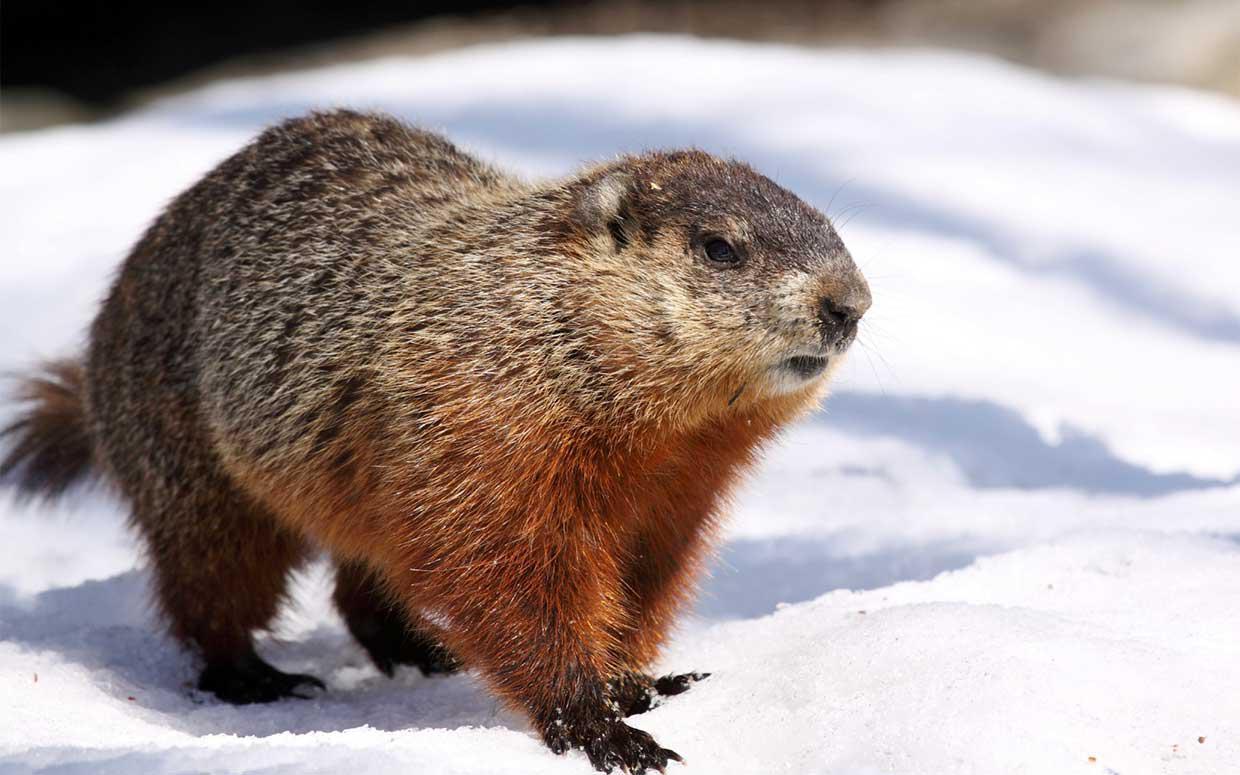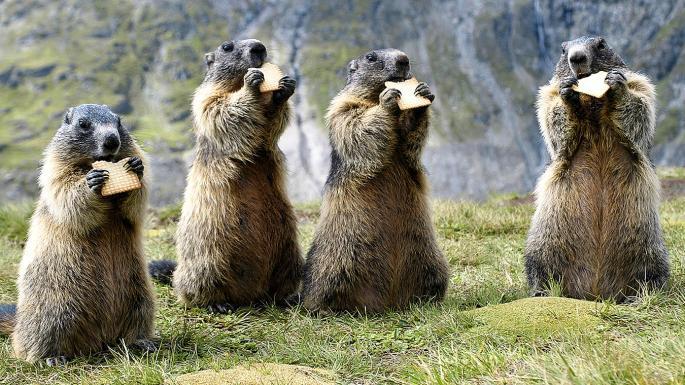The first image is the image on the left, the second image is the image on the right. For the images shown, is this caption "There are two marmots total." true? Answer yes or no. No. The first image is the image on the left, the second image is the image on the right. Considering the images on both sides, is "One image includes multiple marmots that are standing on their hind legs and have their front paws raised." valid? Answer yes or no. Yes. 